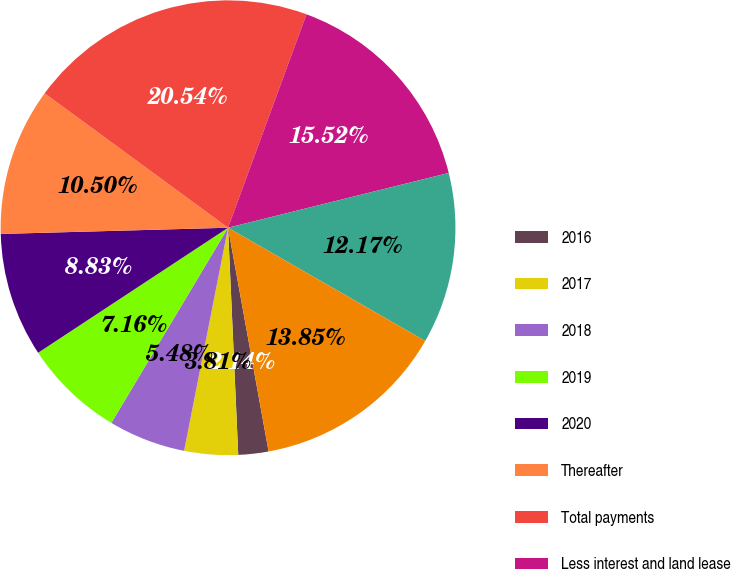<chart> <loc_0><loc_0><loc_500><loc_500><pie_chart><fcel>2016<fcel>2017<fcel>2018<fcel>2019<fcel>2020<fcel>Thereafter<fcel>Total payments<fcel>Less interest and land lease<fcel>Total payments under facility<fcel>Property reverting to landlord<nl><fcel>2.14%<fcel>3.81%<fcel>5.48%<fcel>7.16%<fcel>8.83%<fcel>10.5%<fcel>20.54%<fcel>15.52%<fcel>12.17%<fcel>13.85%<nl></chart> 